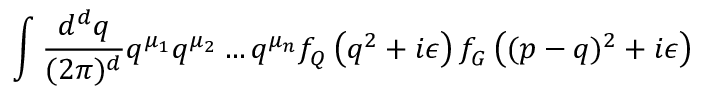<formula> <loc_0><loc_0><loc_500><loc_500>\int \frac { d ^ { d } q } { ( 2 \pi ) ^ { d } } q ^ { \mu _ { 1 } } q ^ { \mu _ { 2 } } \dots q ^ { \mu _ { n } } f _ { Q } \left ( q ^ { 2 } + i \epsilon \right ) f _ { G } \left ( ( p - q ) ^ { 2 } + i \epsilon \right )</formula> 